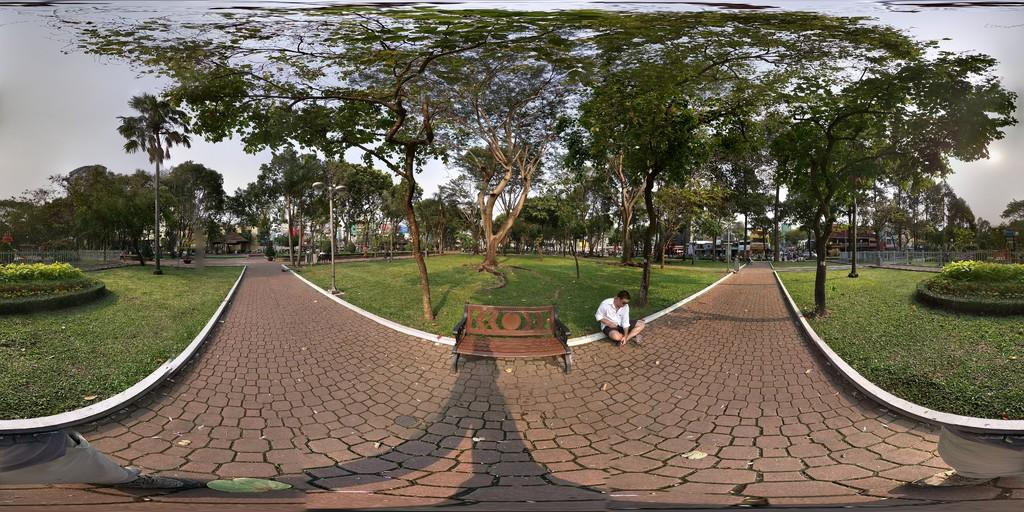What is the person in the image doing? The person is sitting on the ground. What can be seen in the image besides the person? There is a pathway, a bench, grass, a group of trees, poles, a fence, houses, and the sky in the image. Can you describe the sky in the image? The sky is visible in the image and appears cloudy. What type of table is visible in the image? There is no table present in the image. What is the boundary between the person's territory and the neighboring territory in the image? The image does not depict any territories or boundaries, so this question cannot be answered. 